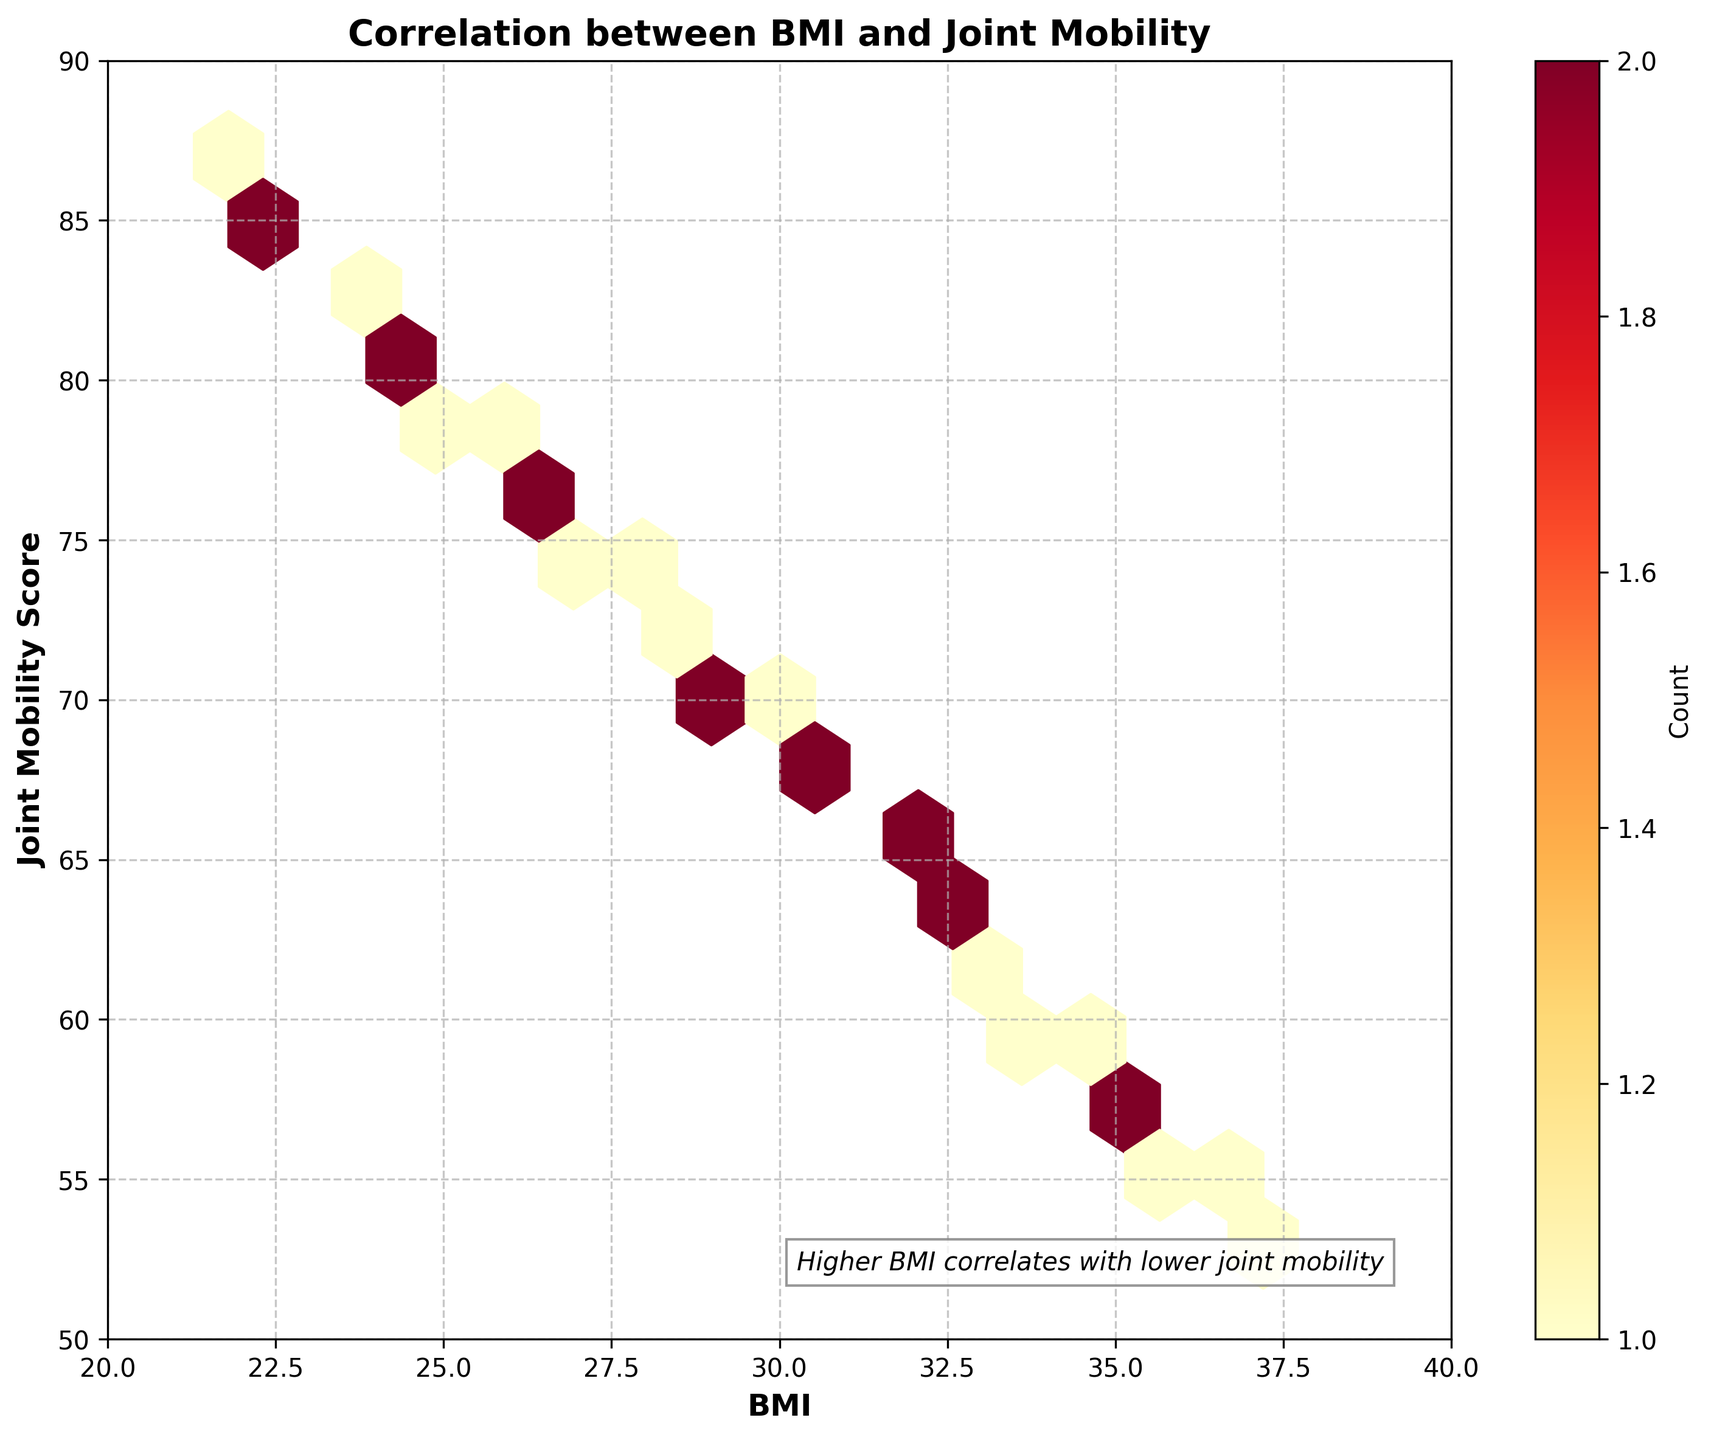What is the title of the figure? The title of the figure is written at the top, and it reads "Correlation between BMI and Joint Mobility".
Answer: Correlation between BMI and Joint Mobility What is the color gradient used for the data points? The color gradient shown in the figure ranges from light yellow to dark red, which indicates the number of data points in a bin.
Answer: Light yellow to dark red What is the relationship between BMI and joint mobility as indicated in the figure? The hexbin plot shows a negative correlation between BMI and joint mobility, as higher BMI values correspond to lower joint mobility scores.
Answer: Negative correlation What is the range of BMI values shown on the x-axis? The x-axis of the plot is labeled BMI, and it ranges from 20 to 40.
Answer: 20 to 40 For BMI values around 22-24, what is the typical joint mobility score range seen in the plot? By inspecting the hexbin plot, it is observed that BMI values around 22-24 correspond to joint mobility scores typically ranging between 80 and 87.
Answer: 80 to 87 Considering the area with highest density, what BMI and joint mobility scores are most common? The highest density area in the plot is indicated by the darkest hexagons, suggesting that BMI values around 30 and joint mobility scores around 68-70 are most common.
Answer: BMI around 30, joint mobility around 68-70 How does joint mobility change as BMI moves from 22 to 36? As BMI increases from 22 to 36, the joint mobility score decreases from about 85 to around 54-58, showing a clear negative trend.
Answer: Decreases from 85 to 54-58 Is there a specific text annotation on the plot? If so, what does it say? The plot has a text annotation in the bottom right corner which states, "Higher BMI correlates with lower joint mobility".
Answer: Higher BMI correlates with lower joint mobility What could be inferred about a patient with a BMI of 25 based on the plot? From the plot, a patient with a BMI of 25 would typically have a joint mobility score around 78-80, based on the density of the hexagons in that region.
Answer: Joint mobility score around 78-80 Where is the color bar located, and what does it indicate? The color bar is located on the right side of the plot and it indicates the count of data points within each hexagonal bin.
Answer: Right side, indicates count of data points 